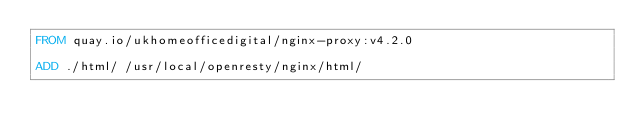<code> <loc_0><loc_0><loc_500><loc_500><_Dockerfile_>FROM quay.io/ukhomeofficedigital/nginx-proxy:v4.2.0

ADD ./html/ /usr/local/openresty/nginx/html/
</code> 